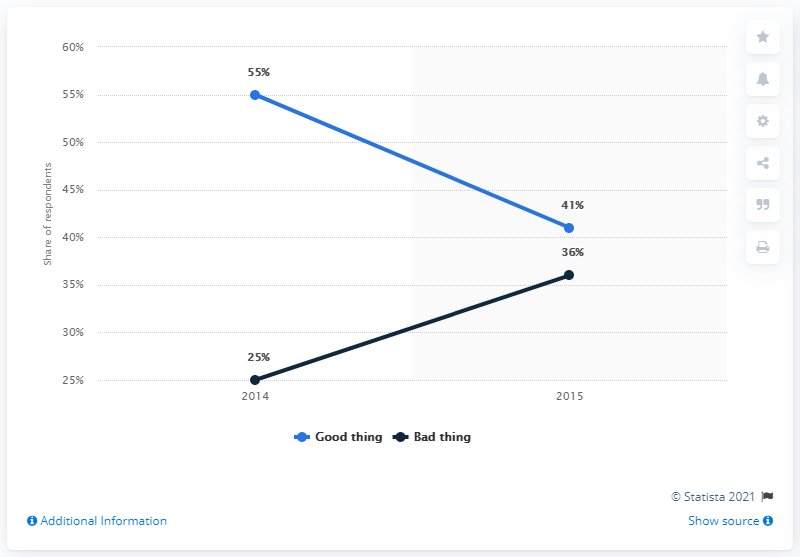Outline some significant characteristics in this image. In 2015, 41% of Germans believed that the Transatlantic Trade and Investment Partnership (TTIP) would be beneficial for their country. 